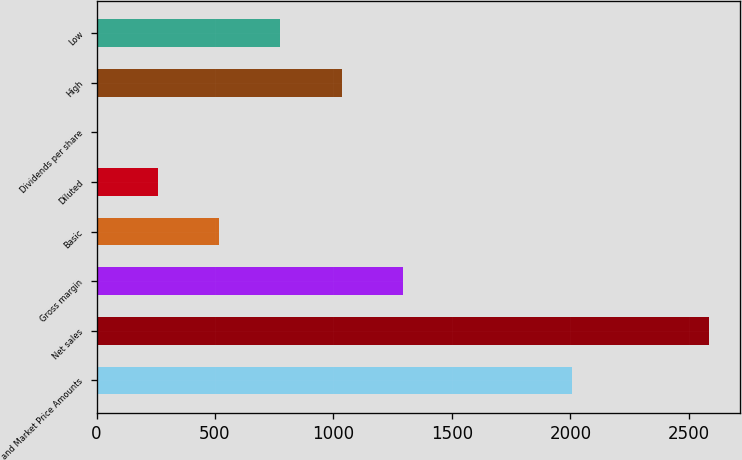<chart> <loc_0><loc_0><loc_500><loc_500><bar_chart><fcel>and Market Price Amounts<fcel>Net sales<fcel>Gross margin<fcel>Basic<fcel>Diluted<fcel>Dividends per share<fcel>High<fcel>Low<nl><fcel>2005<fcel>2585<fcel>1292.66<fcel>517.25<fcel>258.78<fcel>0.31<fcel>1034.19<fcel>775.72<nl></chart> 